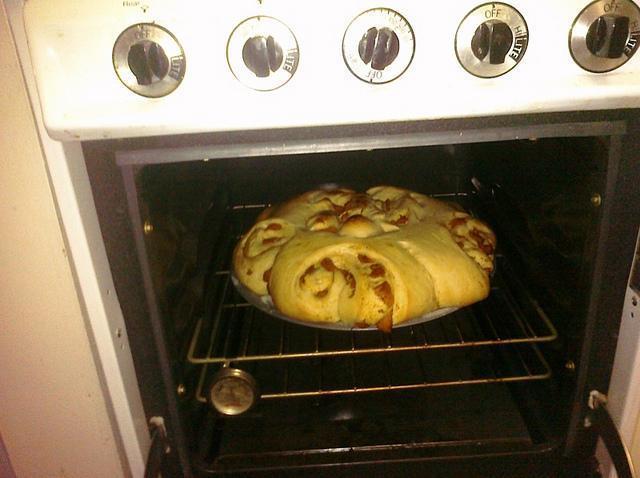How many ovens are there?
Give a very brief answer. 1. How many dogs are on he bench in this image?
Give a very brief answer. 0. 